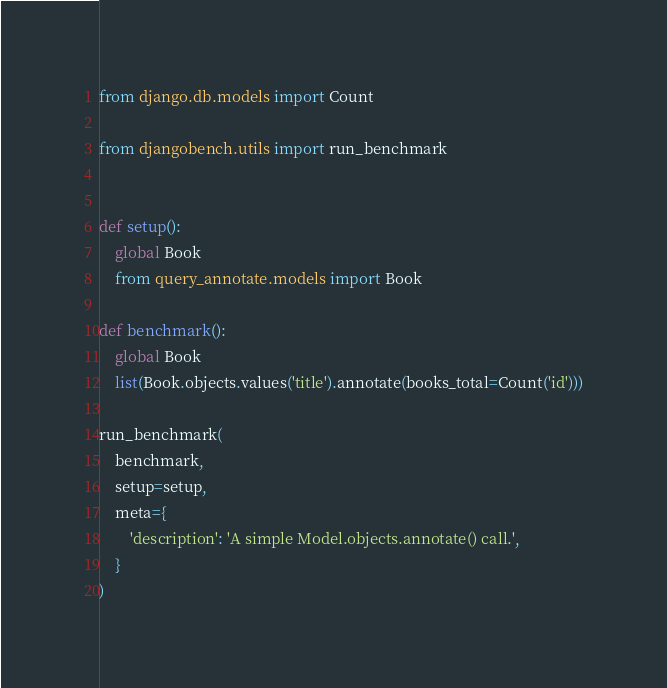<code> <loc_0><loc_0><loc_500><loc_500><_Python_>from django.db.models import Count

from djangobench.utils import run_benchmark


def setup():
    global Book
    from query_annotate.models import Book

def benchmark():
    global Book
    list(Book.objects.values('title').annotate(books_total=Count('id')))

run_benchmark(
    benchmark,
    setup=setup,
    meta={
        'description': 'A simple Model.objects.annotate() call.',
    }
)
</code> 